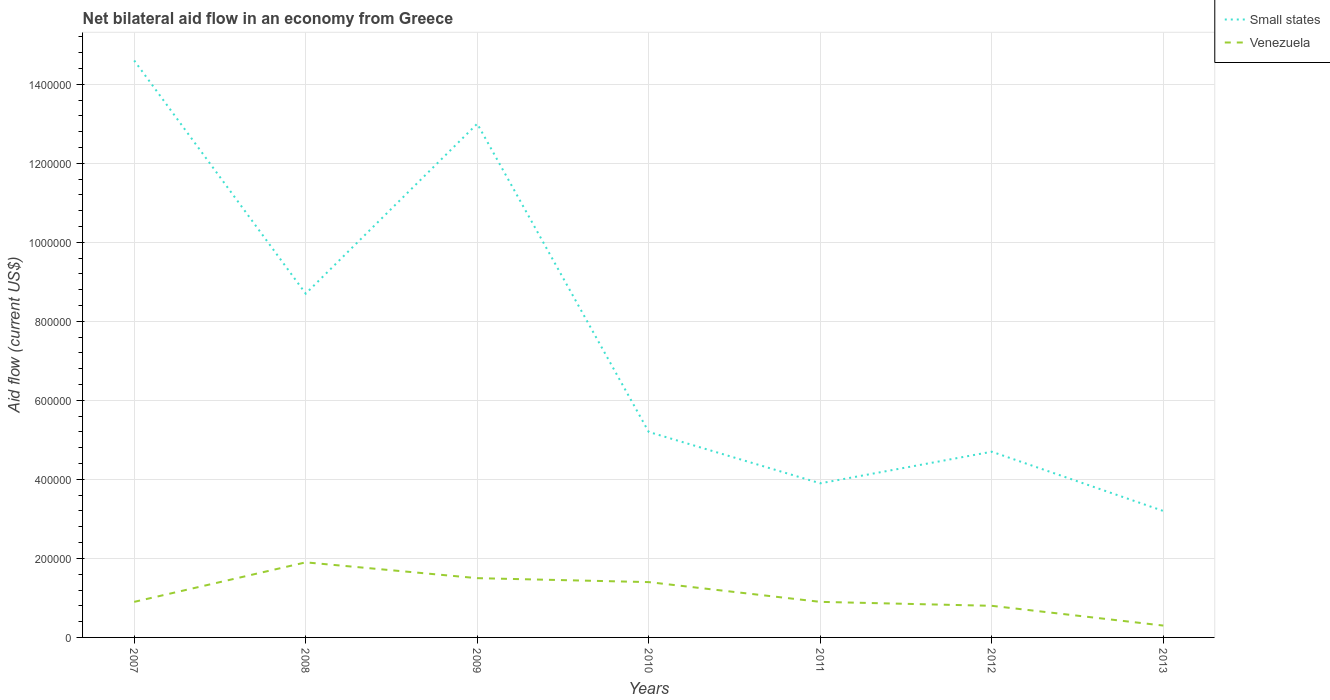What is the total net bilateral aid flow in Small states in the graph?
Give a very brief answer. 4.80e+05. What is the difference between the highest and the second highest net bilateral aid flow in Venezuela?
Your response must be concise. 1.60e+05. Is the net bilateral aid flow in Small states strictly greater than the net bilateral aid flow in Venezuela over the years?
Offer a terse response. No. What is the difference between two consecutive major ticks on the Y-axis?
Provide a succinct answer. 2.00e+05. Are the values on the major ticks of Y-axis written in scientific E-notation?
Offer a very short reply. No. Does the graph contain grids?
Offer a very short reply. Yes. How many legend labels are there?
Provide a succinct answer. 2. How are the legend labels stacked?
Keep it short and to the point. Vertical. What is the title of the graph?
Provide a short and direct response. Net bilateral aid flow in an economy from Greece. What is the label or title of the Y-axis?
Your response must be concise. Aid flow (current US$). What is the Aid flow (current US$) of Small states in 2007?
Give a very brief answer. 1.46e+06. What is the Aid flow (current US$) in Small states in 2008?
Provide a succinct answer. 8.70e+05. What is the Aid flow (current US$) of Venezuela in 2008?
Give a very brief answer. 1.90e+05. What is the Aid flow (current US$) in Small states in 2009?
Provide a succinct answer. 1.30e+06. What is the Aid flow (current US$) of Small states in 2010?
Keep it short and to the point. 5.20e+05. What is the Aid flow (current US$) in Small states in 2011?
Keep it short and to the point. 3.90e+05. What is the Aid flow (current US$) in Venezuela in 2011?
Offer a very short reply. 9.00e+04. What is the Aid flow (current US$) in Small states in 2012?
Your answer should be very brief. 4.70e+05. What is the Aid flow (current US$) of Venezuela in 2012?
Provide a succinct answer. 8.00e+04. Across all years, what is the maximum Aid flow (current US$) of Small states?
Your answer should be compact. 1.46e+06. What is the total Aid flow (current US$) in Small states in the graph?
Provide a short and direct response. 5.33e+06. What is the total Aid flow (current US$) of Venezuela in the graph?
Ensure brevity in your answer.  7.70e+05. What is the difference between the Aid flow (current US$) in Small states in 2007 and that in 2008?
Provide a succinct answer. 5.90e+05. What is the difference between the Aid flow (current US$) of Small states in 2007 and that in 2010?
Offer a terse response. 9.40e+05. What is the difference between the Aid flow (current US$) in Small states in 2007 and that in 2011?
Offer a very short reply. 1.07e+06. What is the difference between the Aid flow (current US$) of Small states in 2007 and that in 2012?
Give a very brief answer. 9.90e+05. What is the difference between the Aid flow (current US$) of Small states in 2007 and that in 2013?
Keep it short and to the point. 1.14e+06. What is the difference between the Aid flow (current US$) in Venezuela in 2007 and that in 2013?
Provide a short and direct response. 6.00e+04. What is the difference between the Aid flow (current US$) of Small states in 2008 and that in 2009?
Your answer should be very brief. -4.30e+05. What is the difference between the Aid flow (current US$) of Small states in 2008 and that in 2010?
Provide a short and direct response. 3.50e+05. What is the difference between the Aid flow (current US$) in Venezuela in 2008 and that in 2010?
Provide a short and direct response. 5.00e+04. What is the difference between the Aid flow (current US$) of Venezuela in 2008 and that in 2011?
Give a very brief answer. 1.00e+05. What is the difference between the Aid flow (current US$) of Small states in 2008 and that in 2013?
Your answer should be very brief. 5.50e+05. What is the difference between the Aid flow (current US$) in Venezuela in 2008 and that in 2013?
Your response must be concise. 1.60e+05. What is the difference between the Aid flow (current US$) in Small states in 2009 and that in 2010?
Keep it short and to the point. 7.80e+05. What is the difference between the Aid flow (current US$) in Small states in 2009 and that in 2011?
Offer a terse response. 9.10e+05. What is the difference between the Aid flow (current US$) of Venezuela in 2009 and that in 2011?
Offer a terse response. 6.00e+04. What is the difference between the Aid flow (current US$) in Small states in 2009 and that in 2012?
Keep it short and to the point. 8.30e+05. What is the difference between the Aid flow (current US$) in Venezuela in 2009 and that in 2012?
Keep it short and to the point. 7.00e+04. What is the difference between the Aid flow (current US$) of Small states in 2009 and that in 2013?
Offer a terse response. 9.80e+05. What is the difference between the Aid flow (current US$) in Small states in 2010 and that in 2011?
Make the answer very short. 1.30e+05. What is the difference between the Aid flow (current US$) of Venezuela in 2010 and that in 2011?
Offer a terse response. 5.00e+04. What is the difference between the Aid flow (current US$) of Venezuela in 2010 and that in 2013?
Offer a very short reply. 1.10e+05. What is the difference between the Aid flow (current US$) in Small states in 2011 and that in 2012?
Keep it short and to the point. -8.00e+04. What is the difference between the Aid flow (current US$) in Venezuela in 2011 and that in 2012?
Keep it short and to the point. 10000. What is the difference between the Aid flow (current US$) of Small states in 2011 and that in 2013?
Your answer should be very brief. 7.00e+04. What is the difference between the Aid flow (current US$) of Venezuela in 2011 and that in 2013?
Offer a terse response. 6.00e+04. What is the difference between the Aid flow (current US$) of Small states in 2007 and the Aid flow (current US$) of Venezuela in 2008?
Your answer should be compact. 1.27e+06. What is the difference between the Aid flow (current US$) of Small states in 2007 and the Aid flow (current US$) of Venezuela in 2009?
Give a very brief answer. 1.31e+06. What is the difference between the Aid flow (current US$) in Small states in 2007 and the Aid flow (current US$) in Venezuela in 2010?
Your answer should be very brief. 1.32e+06. What is the difference between the Aid flow (current US$) of Small states in 2007 and the Aid flow (current US$) of Venezuela in 2011?
Your answer should be compact. 1.37e+06. What is the difference between the Aid flow (current US$) in Small states in 2007 and the Aid flow (current US$) in Venezuela in 2012?
Keep it short and to the point. 1.38e+06. What is the difference between the Aid flow (current US$) of Small states in 2007 and the Aid flow (current US$) of Venezuela in 2013?
Offer a very short reply. 1.43e+06. What is the difference between the Aid flow (current US$) of Small states in 2008 and the Aid flow (current US$) of Venezuela in 2009?
Ensure brevity in your answer.  7.20e+05. What is the difference between the Aid flow (current US$) of Small states in 2008 and the Aid flow (current US$) of Venezuela in 2010?
Provide a succinct answer. 7.30e+05. What is the difference between the Aid flow (current US$) in Small states in 2008 and the Aid flow (current US$) in Venezuela in 2011?
Your answer should be very brief. 7.80e+05. What is the difference between the Aid flow (current US$) in Small states in 2008 and the Aid flow (current US$) in Venezuela in 2012?
Offer a terse response. 7.90e+05. What is the difference between the Aid flow (current US$) of Small states in 2008 and the Aid flow (current US$) of Venezuela in 2013?
Make the answer very short. 8.40e+05. What is the difference between the Aid flow (current US$) of Small states in 2009 and the Aid flow (current US$) of Venezuela in 2010?
Your response must be concise. 1.16e+06. What is the difference between the Aid flow (current US$) in Small states in 2009 and the Aid flow (current US$) in Venezuela in 2011?
Provide a succinct answer. 1.21e+06. What is the difference between the Aid flow (current US$) of Small states in 2009 and the Aid flow (current US$) of Venezuela in 2012?
Offer a terse response. 1.22e+06. What is the difference between the Aid flow (current US$) in Small states in 2009 and the Aid flow (current US$) in Venezuela in 2013?
Keep it short and to the point. 1.27e+06. What is the difference between the Aid flow (current US$) in Small states in 2010 and the Aid flow (current US$) in Venezuela in 2013?
Your answer should be compact. 4.90e+05. What is the average Aid flow (current US$) in Small states per year?
Keep it short and to the point. 7.61e+05. What is the average Aid flow (current US$) in Venezuela per year?
Your response must be concise. 1.10e+05. In the year 2007, what is the difference between the Aid flow (current US$) in Small states and Aid flow (current US$) in Venezuela?
Your answer should be very brief. 1.37e+06. In the year 2008, what is the difference between the Aid flow (current US$) in Small states and Aid flow (current US$) in Venezuela?
Provide a succinct answer. 6.80e+05. In the year 2009, what is the difference between the Aid flow (current US$) of Small states and Aid flow (current US$) of Venezuela?
Make the answer very short. 1.15e+06. In the year 2010, what is the difference between the Aid flow (current US$) of Small states and Aid flow (current US$) of Venezuela?
Offer a terse response. 3.80e+05. In the year 2011, what is the difference between the Aid flow (current US$) of Small states and Aid flow (current US$) of Venezuela?
Offer a very short reply. 3.00e+05. What is the ratio of the Aid flow (current US$) of Small states in 2007 to that in 2008?
Offer a terse response. 1.68. What is the ratio of the Aid flow (current US$) of Venezuela in 2007 to that in 2008?
Offer a terse response. 0.47. What is the ratio of the Aid flow (current US$) in Small states in 2007 to that in 2009?
Your answer should be very brief. 1.12. What is the ratio of the Aid flow (current US$) in Small states in 2007 to that in 2010?
Offer a terse response. 2.81. What is the ratio of the Aid flow (current US$) of Venezuela in 2007 to that in 2010?
Ensure brevity in your answer.  0.64. What is the ratio of the Aid flow (current US$) of Small states in 2007 to that in 2011?
Offer a terse response. 3.74. What is the ratio of the Aid flow (current US$) of Small states in 2007 to that in 2012?
Your answer should be very brief. 3.11. What is the ratio of the Aid flow (current US$) in Venezuela in 2007 to that in 2012?
Provide a succinct answer. 1.12. What is the ratio of the Aid flow (current US$) in Small states in 2007 to that in 2013?
Make the answer very short. 4.56. What is the ratio of the Aid flow (current US$) of Venezuela in 2007 to that in 2013?
Ensure brevity in your answer.  3. What is the ratio of the Aid flow (current US$) of Small states in 2008 to that in 2009?
Provide a short and direct response. 0.67. What is the ratio of the Aid flow (current US$) in Venezuela in 2008 to that in 2009?
Make the answer very short. 1.27. What is the ratio of the Aid flow (current US$) of Small states in 2008 to that in 2010?
Your response must be concise. 1.67. What is the ratio of the Aid flow (current US$) in Venezuela in 2008 to that in 2010?
Make the answer very short. 1.36. What is the ratio of the Aid flow (current US$) in Small states in 2008 to that in 2011?
Offer a terse response. 2.23. What is the ratio of the Aid flow (current US$) of Venezuela in 2008 to that in 2011?
Provide a short and direct response. 2.11. What is the ratio of the Aid flow (current US$) in Small states in 2008 to that in 2012?
Provide a succinct answer. 1.85. What is the ratio of the Aid flow (current US$) in Venezuela in 2008 to that in 2012?
Give a very brief answer. 2.38. What is the ratio of the Aid flow (current US$) in Small states in 2008 to that in 2013?
Make the answer very short. 2.72. What is the ratio of the Aid flow (current US$) of Venezuela in 2008 to that in 2013?
Your response must be concise. 6.33. What is the ratio of the Aid flow (current US$) in Venezuela in 2009 to that in 2010?
Offer a very short reply. 1.07. What is the ratio of the Aid flow (current US$) of Small states in 2009 to that in 2011?
Your answer should be compact. 3.33. What is the ratio of the Aid flow (current US$) of Venezuela in 2009 to that in 2011?
Make the answer very short. 1.67. What is the ratio of the Aid flow (current US$) of Small states in 2009 to that in 2012?
Provide a succinct answer. 2.77. What is the ratio of the Aid flow (current US$) of Venezuela in 2009 to that in 2012?
Provide a succinct answer. 1.88. What is the ratio of the Aid flow (current US$) in Small states in 2009 to that in 2013?
Your answer should be compact. 4.06. What is the ratio of the Aid flow (current US$) in Venezuela in 2010 to that in 2011?
Your answer should be very brief. 1.56. What is the ratio of the Aid flow (current US$) in Small states in 2010 to that in 2012?
Offer a terse response. 1.11. What is the ratio of the Aid flow (current US$) in Small states in 2010 to that in 2013?
Your answer should be compact. 1.62. What is the ratio of the Aid flow (current US$) in Venezuela in 2010 to that in 2013?
Offer a terse response. 4.67. What is the ratio of the Aid flow (current US$) in Small states in 2011 to that in 2012?
Make the answer very short. 0.83. What is the ratio of the Aid flow (current US$) in Small states in 2011 to that in 2013?
Provide a short and direct response. 1.22. What is the ratio of the Aid flow (current US$) of Venezuela in 2011 to that in 2013?
Give a very brief answer. 3. What is the ratio of the Aid flow (current US$) in Small states in 2012 to that in 2013?
Your response must be concise. 1.47. What is the ratio of the Aid flow (current US$) in Venezuela in 2012 to that in 2013?
Offer a terse response. 2.67. What is the difference between the highest and the second highest Aid flow (current US$) of Venezuela?
Offer a very short reply. 4.00e+04. What is the difference between the highest and the lowest Aid flow (current US$) of Small states?
Make the answer very short. 1.14e+06. 